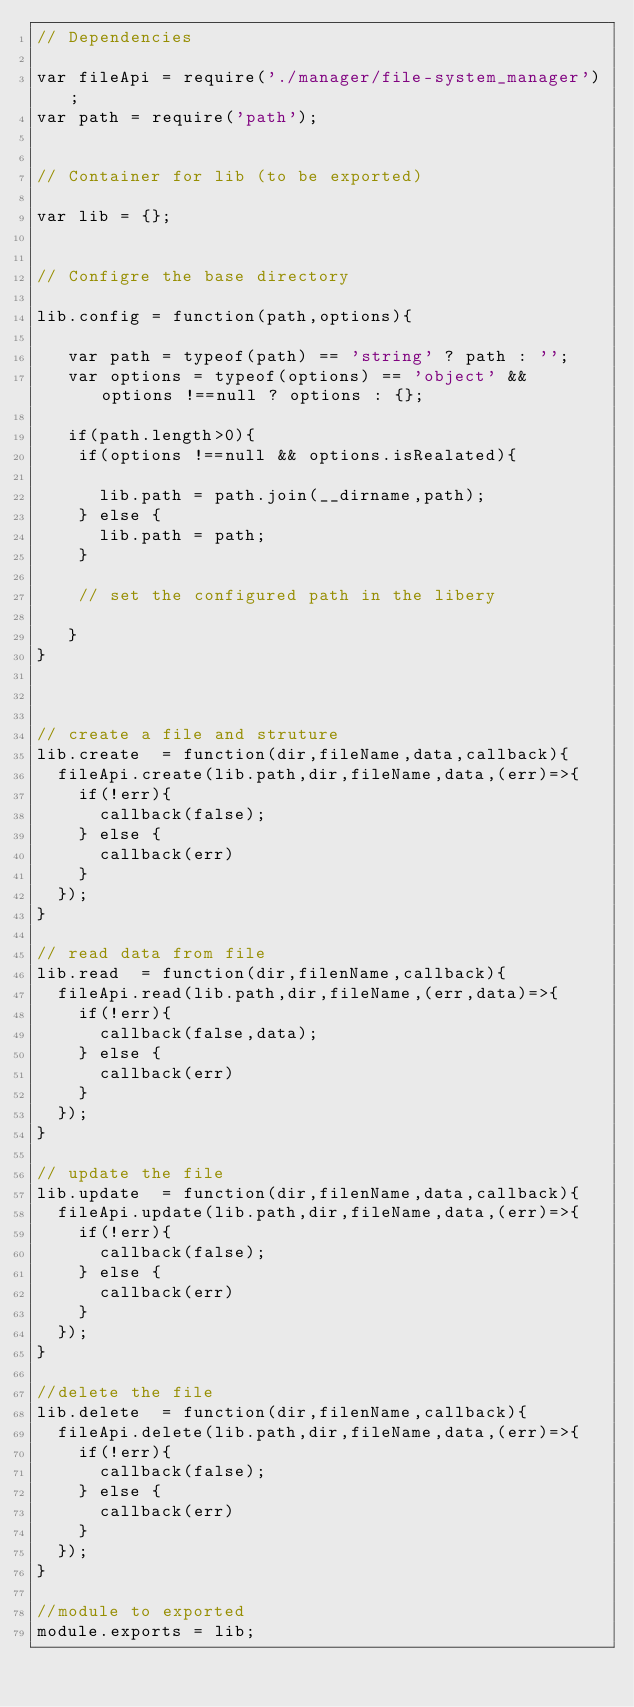Convert code to text. <code><loc_0><loc_0><loc_500><loc_500><_JavaScript_>// Dependencies 

var fileApi = require('./manager/file-system_manager');
var path = require('path');


// Container for lib (to be exported)

var lib = {};


// Configre the base directory

lib.config = function(path,options){

	 var path = typeof(path) == 'string' ? path : '';
	 var options = typeof(options) == 'object' && options !==null ? options : {};

	 if(path.length>0){
	 	if(options !==null && options.isRealated){

	 		lib.path = path.join(__dirname,path);
	 	} else {
	 		lib.path = path;
	 	}

	 	// set the configured path in the libery

	 }
}



// create a file and struture
lib.create  = function(dir,fileName,data,callback){
	fileApi.create(lib.path,dir,fileName,data,(err)=>{
		if(!err){
			callback(false);
		} else {
			callback(err)
		}
	});
}

// read data from file
lib.read  = function(dir,filenName,callback){
	fileApi.read(lib.path,dir,fileName,(err,data)=>{
		if(!err){
			callback(false,data);
		} else {
			callback(err)
		}
	});
}

// update the file 
lib.update  = function(dir,filenName,data,callback){
	fileApi.update(lib.path,dir,fileName,data,(err)=>{
		if(!err){
			callback(false);
		} else {
			callback(err)
		}
	});
}

//delete the file
lib.delete  = function(dir,filenName,callback){
	fileApi.delete(lib.path,dir,fileName,data,(err)=>{
		if(!err){
			callback(false);
		} else {
			callback(err)
		}
	});
}

//module to exported
module.exports = lib;</code> 